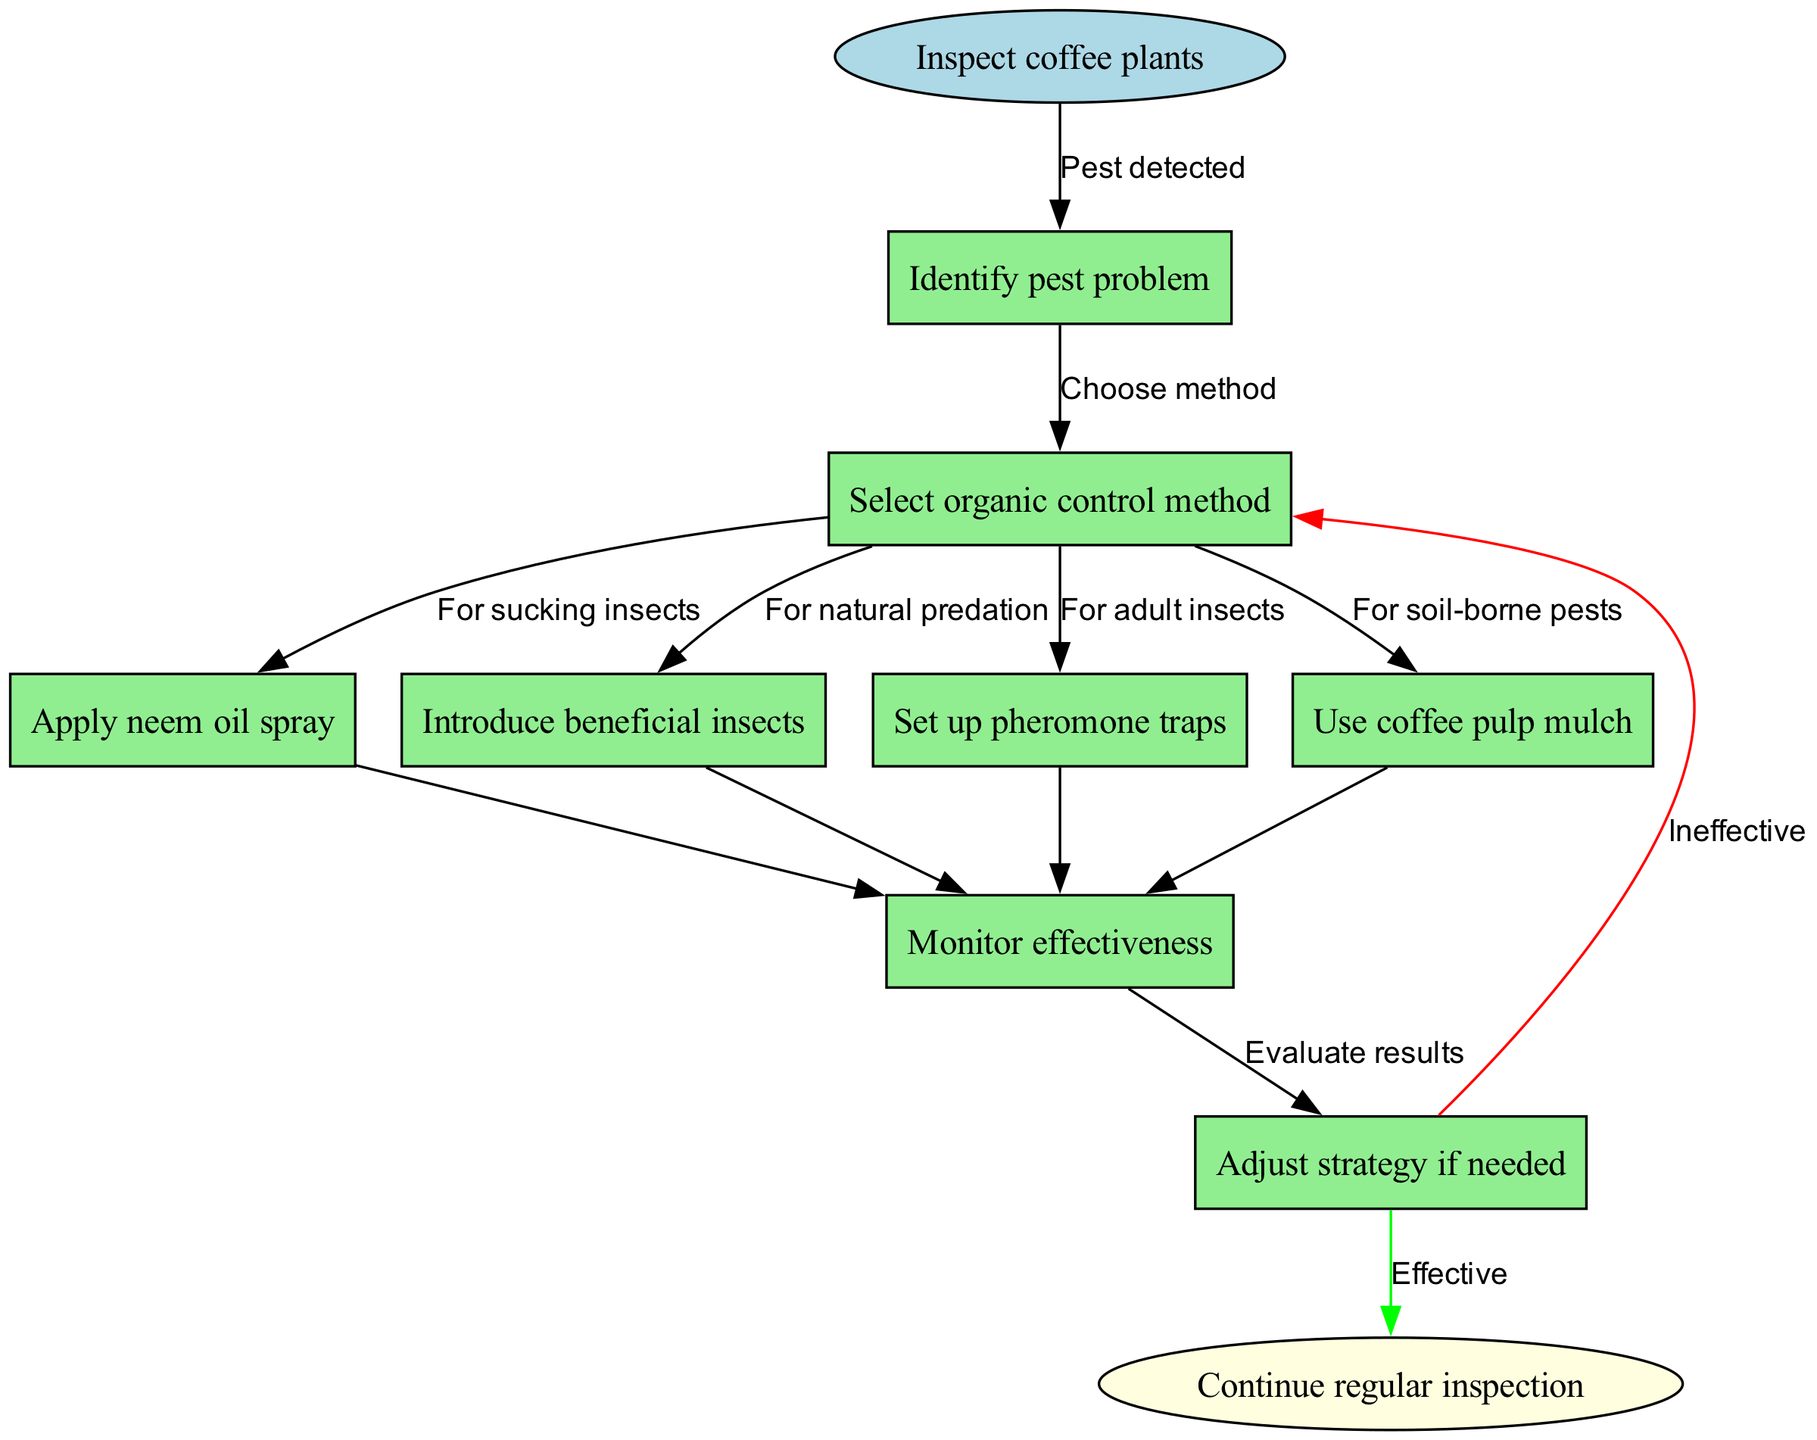What is the first step in the organic pest control process? The diagram starts with the "Inspect coffee plants" node, which is labeled as the first step in the process.
Answer: Inspect coffee plants How many methods can be selected after identifying the pest problem? From the node labeled "Identify pest problem," there are five options listed in the diagram to choose from, corresponding to different organic control methods.
Answer: 5 What organic control method is used for sucking insects? The diagram indicates that the "Apply neem oil spray" node is specifically for controlling sucking insects, as illustrated by the directed edge connecting these nodes.
Answer: Apply neem oil spray What are the two possible outcomes after monitoring effectiveness? Following the "Monitor effectiveness" node, the diagram shows two directed edges leading to either "Ineffective" or "Effective," indicating the result of the pest control strategies applied.
Answer: Ineffective, Effective If the strategy is ineffective, what should you do next? The flow chart indicates that if the strategy is found to be ineffective, the subsequent step is to adjust the strategy according to the edge leading back to the "Identify pest problem" node.
Answer: Adjust strategy if needed What node follows the "Introduce beneficial insects" method? After the "Introduce beneficial insects" node, the flow chart directs to the "Monitor effectiveness" node, showing the process of evaluating the introduced control method.
Answer: Monitor effectiveness What does "Set up pheromone traps" control for? The edge leading from the "Identify pest problem" node to the "Set up pheromone traps" node suggests this method is employed specifically for controlling adult insects, as indicated in the process description.
Answer: For adult insects What happens if the strategy is effective? The diagram shows that if the outcomes from the "Monitor effectiveness" node are effective, the process leads to the "Continue regular inspection" node, signifying the end of the immediate pest control cycle.
Answer: Continue regular inspection How many total nodes are in the diagram? The total number of nodes can be counted as there is one starting node, five control method nodes, one monitoring node, one adjusting strategy node, and one end node, adding up to a total of eight nodes.
Answer: 8 